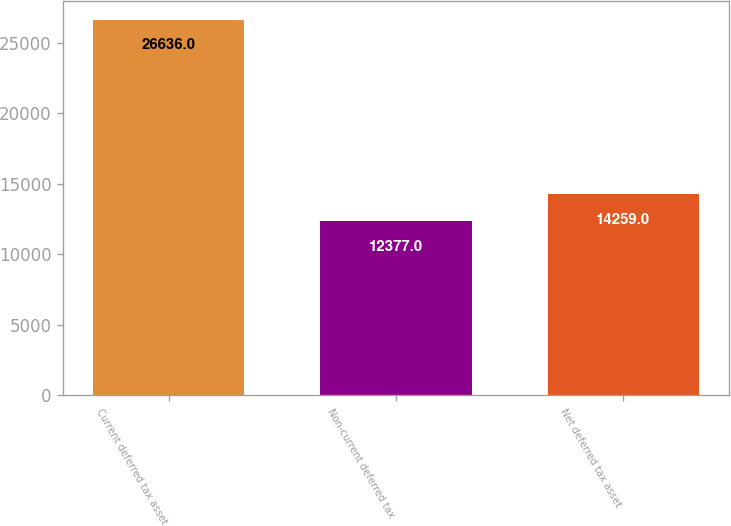Convert chart to OTSL. <chart><loc_0><loc_0><loc_500><loc_500><bar_chart><fcel>Current deferred tax asset<fcel>Non-current deferred tax<fcel>Net deferred tax asset<nl><fcel>26636<fcel>12377<fcel>14259<nl></chart> 